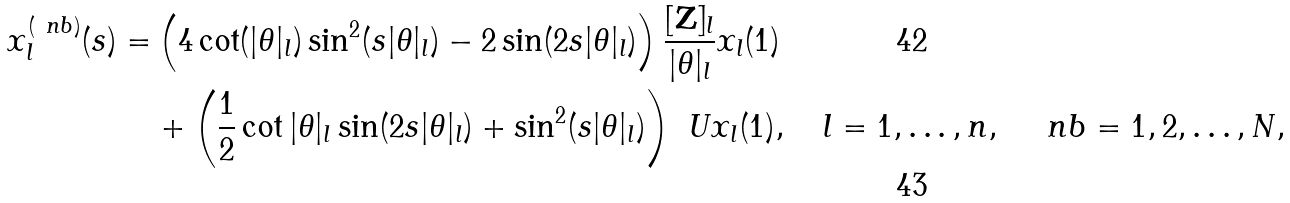Convert formula to latex. <formula><loc_0><loc_0><loc_500><loc_500>x ^ { ( \ n b ) } _ { l } ( s ) = & \left ( 4 \cot ( | \theta | _ { l } ) \sin ^ { 2 } ( s | \theta | _ { l } ) - 2 \sin ( 2 s | \theta | _ { l } ) \right ) \frac { [ \mathbf Z ] _ { l } } { | \theta | _ { l } } x _ { l } ( 1 ) \\ & + \left ( \frac { 1 } { 2 } \cot | \theta | _ { l } \sin ( 2 s | \theta | _ { l } ) + \sin ^ { 2 } ( s | \theta | _ { l } ) \right ) \ U x _ { l } ( 1 ) , \quad l = 1 , \dots , n , \quad \ n b = 1 , 2 , \dots , N ,</formula> 